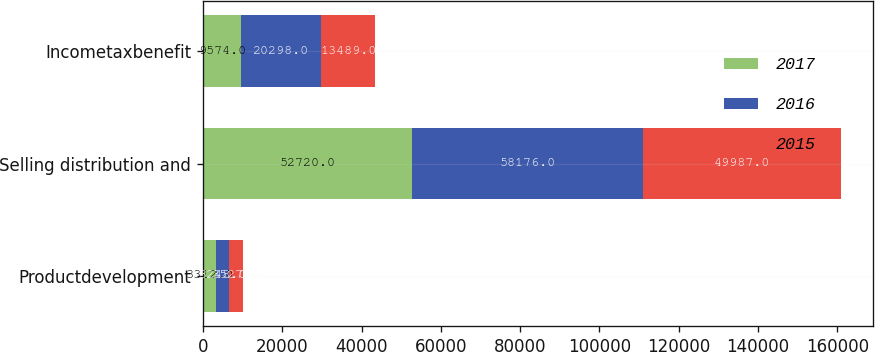Convert chart. <chart><loc_0><loc_0><loc_500><loc_500><stacked_bar_chart><ecel><fcel>Productdevelopment<fcel>Selling distribution and<fcel>Incometaxbenefit<nl><fcel>2017<fcel>3312<fcel>52720<fcel>9574<nl><fcel>2016<fcel>3248<fcel>58176<fcel>20298<nl><fcel>2015<fcel>3527<fcel>49987<fcel>13489<nl></chart> 